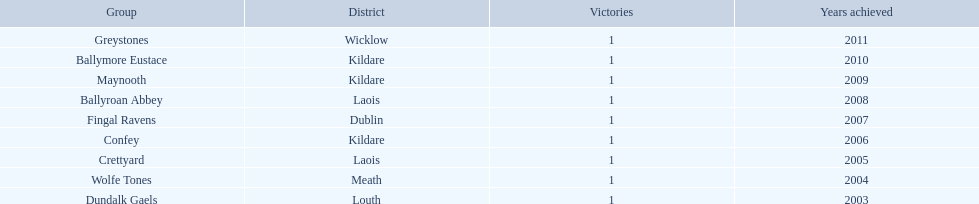Which county accumulated the greatest number of triumphs? Kildare. 